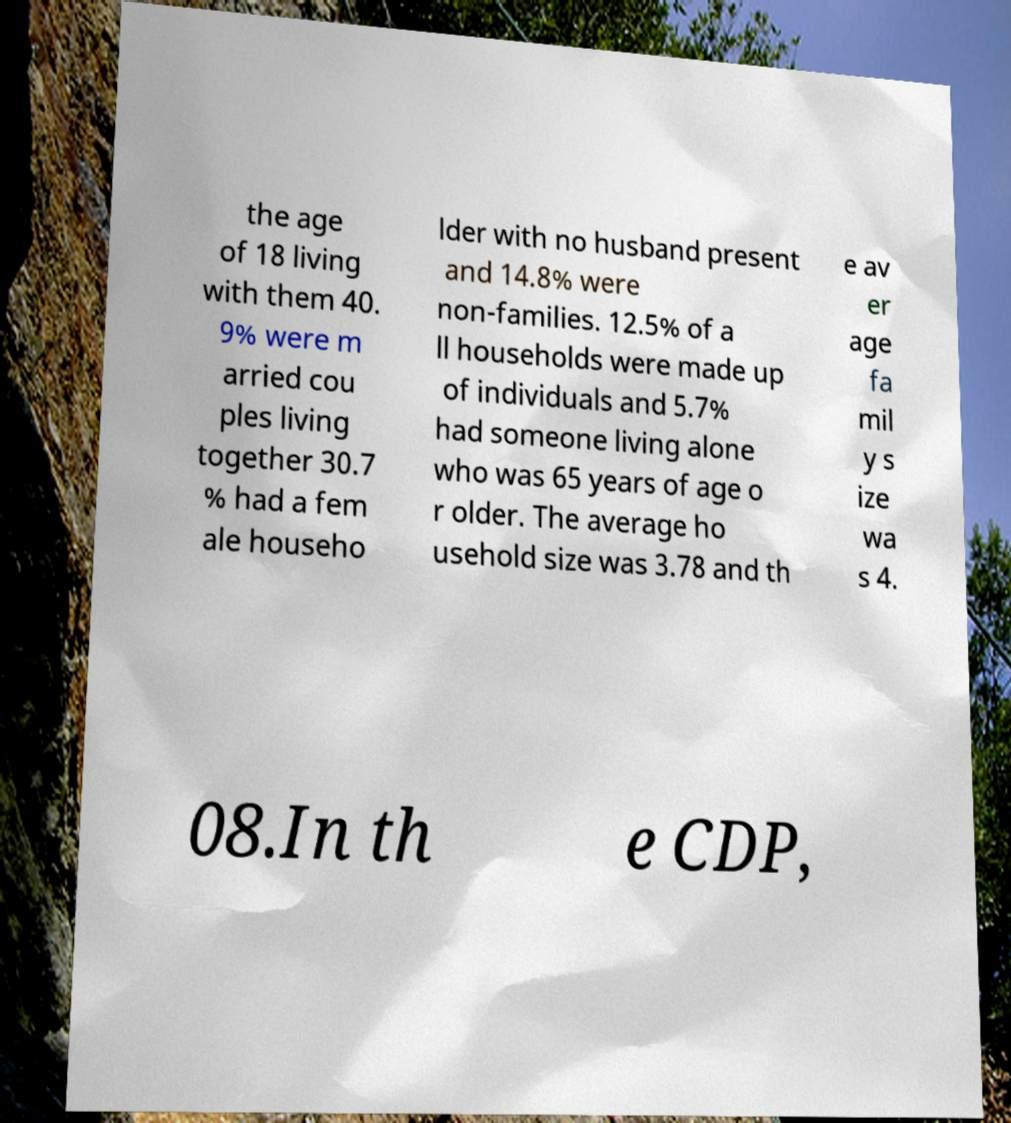Please identify and transcribe the text found in this image. the age of 18 living with them 40. 9% were m arried cou ples living together 30.7 % had a fem ale househo lder with no husband present and 14.8% were non-families. 12.5% of a ll households were made up of individuals and 5.7% had someone living alone who was 65 years of age o r older. The average ho usehold size was 3.78 and th e av er age fa mil y s ize wa s 4. 08.In th e CDP, 